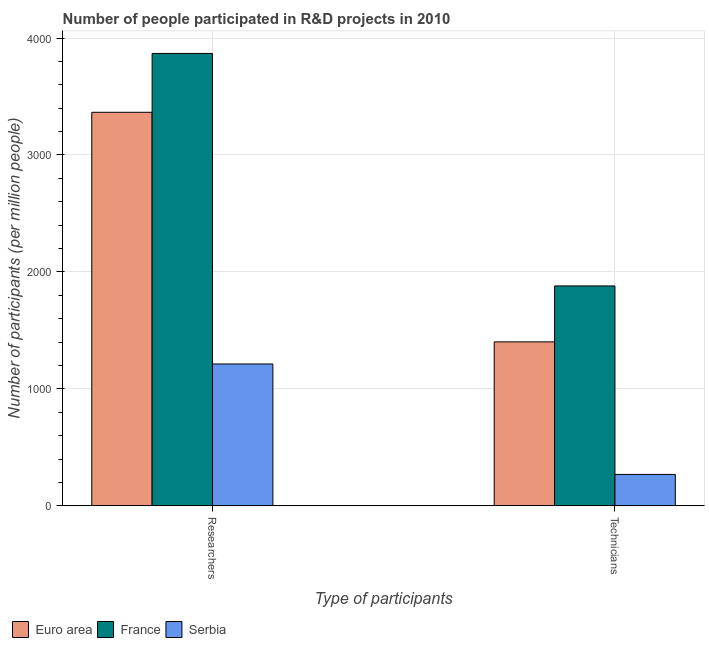Are the number of bars per tick equal to the number of legend labels?
Your answer should be very brief. Yes. How many bars are there on the 2nd tick from the right?
Provide a short and direct response. 3. What is the label of the 1st group of bars from the left?
Provide a short and direct response. Researchers. What is the number of researchers in Serbia?
Give a very brief answer. 1212.59. Across all countries, what is the maximum number of technicians?
Your answer should be compact. 1879.95. Across all countries, what is the minimum number of researchers?
Keep it short and to the point. 1212.59. In which country was the number of technicians minimum?
Your answer should be very brief. Serbia. What is the total number of researchers in the graph?
Offer a very short reply. 8445.38. What is the difference between the number of technicians in Euro area and that in France?
Offer a terse response. -478.28. What is the difference between the number of technicians in Serbia and the number of researchers in France?
Offer a very short reply. -3599.96. What is the average number of technicians per country?
Offer a very short reply. 1183.22. What is the difference between the number of technicians and number of researchers in Euro area?
Make the answer very short. -1963.12. What is the ratio of the number of technicians in Euro area to that in Serbia?
Your answer should be compact. 5.23. Is the number of technicians in Euro area less than that in France?
Ensure brevity in your answer.  Yes. What does the 3rd bar from the right in Technicians represents?
Provide a succinct answer. Euro area. How many countries are there in the graph?
Give a very brief answer. 3. Are the values on the major ticks of Y-axis written in scientific E-notation?
Your answer should be very brief. No. How many legend labels are there?
Provide a short and direct response. 3. How are the legend labels stacked?
Provide a short and direct response. Horizontal. What is the title of the graph?
Your answer should be compact. Number of people participated in R&D projects in 2010. Does "Congo (Republic)" appear as one of the legend labels in the graph?
Make the answer very short. No. What is the label or title of the X-axis?
Provide a short and direct response. Type of participants. What is the label or title of the Y-axis?
Keep it short and to the point. Number of participants (per million people). What is the Number of participants (per million people) in Euro area in Researchers?
Your response must be concise. 3364.79. What is the Number of participants (per million people) of France in Researchers?
Give a very brief answer. 3867.99. What is the Number of participants (per million people) in Serbia in Researchers?
Give a very brief answer. 1212.59. What is the Number of participants (per million people) of Euro area in Technicians?
Make the answer very short. 1401.67. What is the Number of participants (per million people) in France in Technicians?
Give a very brief answer. 1879.95. What is the Number of participants (per million people) in Serbia in Technicians?
Give a very brief answer. 268.03. Across all Type of participants, what is the maximum Number of participants (per million people) in Euro area?
Offer a very short reply. 3364.79. Across all Type of participants, what is the maximum Number of participants (per million people) in France?
Offer a very short reply. 3867.99. Across all Type of participants, what is the maximum Number of participants (per million people) in Serbia?
Give a very brief answer. 1212.59. Across all Type of participants, what is the minimum Number of participants (per million people) in Euro area?
Provide a succinct answer. 1401.67. Across all Type of participants, what is the minimum Number of participants (per million people) of France?
Offer a terse response. 1879.95. Across all Type of participants, what is the minimum Number of participants (per million people) in Serbia?
Ensure brevity in your answer.  268.03. What is the total Number of participants (per million people) of Euro area in the graph?
Ensure brevity in your answer.  4766.46. What is the total Number of participants (per million people) in France in the graph?
Ensure brevity in your answer.  5747.94. What is the total Number of participants (per million people) of Serbia in the graph?
Provide a short and direct response. 1480.62. What is the difference between the Number of participants (per million people) in Euro area in Researchers and that in Technicians?
Keep it short and to the point. 1963.12. What is the difference between the Number of participants (per million people) in France in Researchers and that in Technicians?
Make the answer very short. 1988.05. What is the difference between the Number of participants (per million people) of Serbia in Researchers and that in Technicians?
Provide a short and direct response. 944.56. What is the difference between the Number of participants (per million people) of Euro area in Researchers and the Number of participants (per million people) of France in Technicians?
Offer a terse response. 1484.85. What is the difference between the Number of participants (per million people) in Euro area in Researchers and the Number of participants (per million people) in Serbia in Technicians?
Ensure brevity in your answer.  3096.76. What is the difference between the Number of participants (per million people) of France in Researchers and the Number of participants (per million people) of Serbia in Technicians?
Ensure brevity in your answer.  3599.96. What is the average Number of participants (per million people) of Euro area per Type of participants?
Your answer should be compact. 2383.23. What is the average Number of participants (per million people) of France per Type of participants?
Offer a very short reply. 2873.97. What is the average Number of participants (per million people) in Serbia per Type of participants?
Offer a terse response. 740.31. What is the difference between the Number of participants (per million people) in Euro area and Number of participants (per million people) in France in Researchers?
Your answer should be compact. -503.2. What is the difference between the Number of participants (per million people) in Euro area and Number of participants (per million people) in Serbia in Researchers?
Provide a short and direct response. 2152.2. What is the difference between the Number of participants (per million people) of France and Number of participants (per million people) of Serbia in Researchers?
Offer a very short reply. 2655.4. What is the difference between the Number of participants (per million people) in Euro area and Number of participants (per million people) in France in Technicians?
Provide a succinct answer. -478.28. What is the difference between the Number of participants (per million people) of Euro area and Number of participants (per million people) of Serbia in Technicians?
Your answer should be compact. 1133.64. What is the difference between the Number of participants (per million people) of France and Number of participants (per million people) of Serbia in Technicians?
Your answer should be compact. 1611.92. What is the ratio of the Number of participants (per million people) in Euro area in Researchers to that in Technicians?
Ensure brevity in your answer.  2.4. What is the ratio of the Number of participants (per million people) of France in Researchers to that in Technicians?
Your answer should be very brief. 2.06. What is the ratio of the Number of participants (per million people) of Serbia in Researchers to that in Technicians?
Offer a very short reply. 4.52. What is the difference between the highest and the second highest Number of participants (per million people) of Euro area?
Your answer should be very brief. 1963.12. What is the difference between the highest and the second highest Number of participants (per million people) in France?
Ensure brevity in your answer.  1988.05. What is the difference between the highest and the second highest Number of participants (per million people) of Serbia?
Make the answer very short. 944.56. What is the difference between the highest and the lowest Number of participants (per million people) of Euro area?
Offer a very short reply. 1963.12. What is the difference between the highest and the lowest Number of participants (per million people) of France?
Your response must be concise. 1988.05. What is the difference between the highest and the lowest Number of participants (per million people) in Serbia?
Keep it short and to the point. 944.56. 